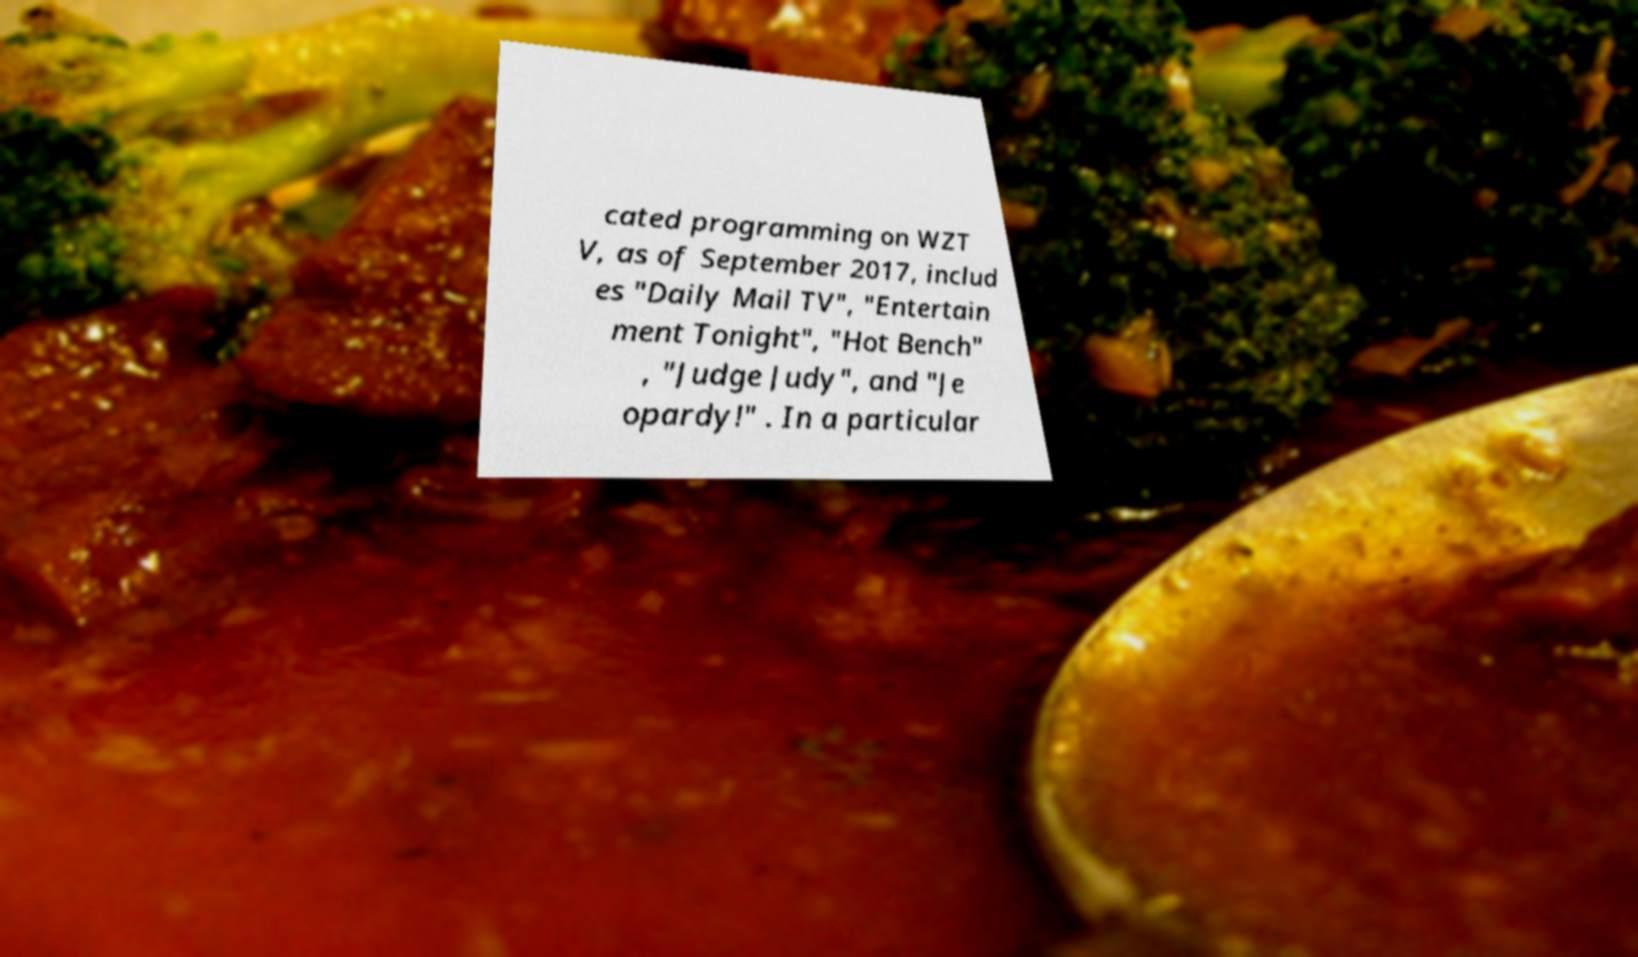Please identify and transcribe the text found in this image. cated programming on WZT V, as of September 2017, includ es "Daily Mail TV", "Entertain ment Tonight", "Hot Bench" , "Judge Judy", and "Je opardy!" . In a particular 